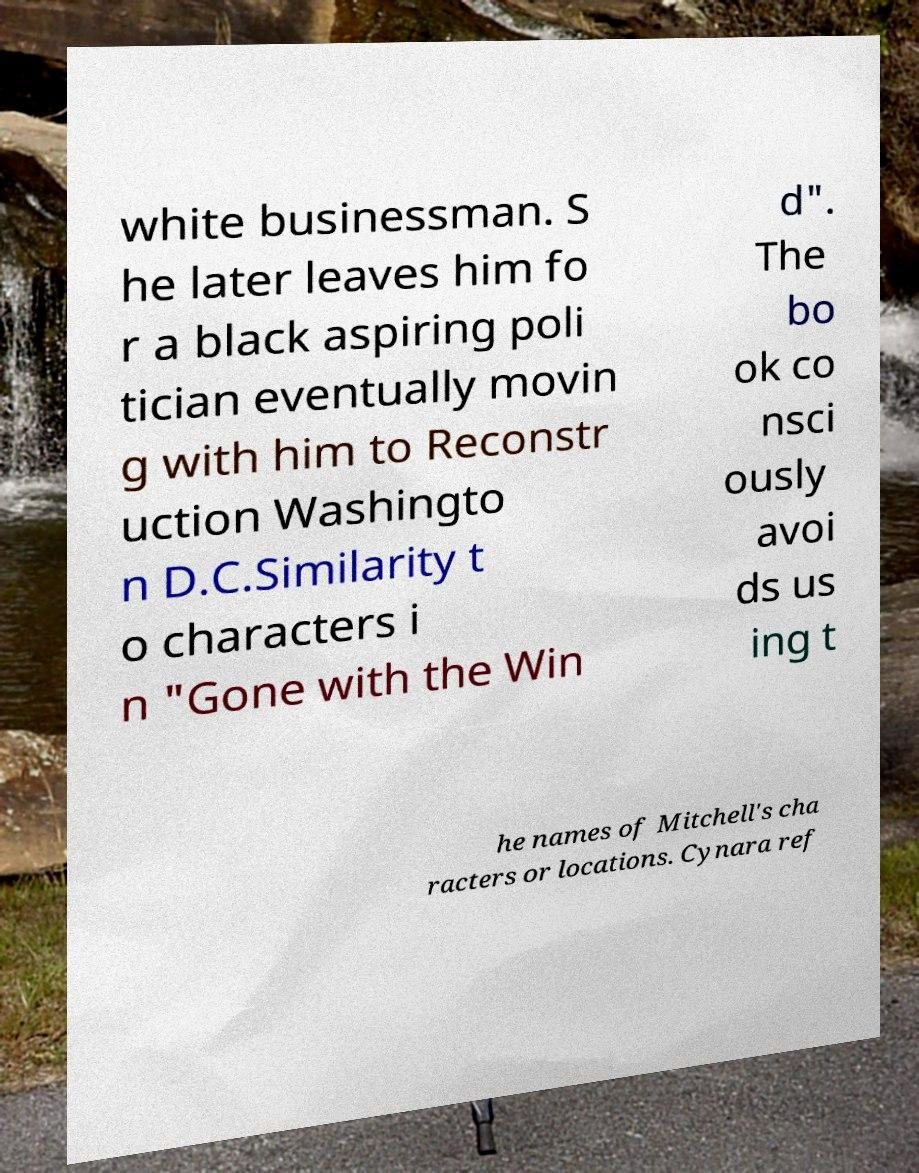Please read and relay the text visible in this image. What does it say? white businessman. S he later leaves him fo r a black aspiring poli tician eventually movin g with him to Reconstr uction Washingto n D.C.Similarity t o characters i n "Gone with the Win d". The bo ok co nsci ously avoi ds us ing t he names of Mitchell's cha racters or locations. Cynara ref 